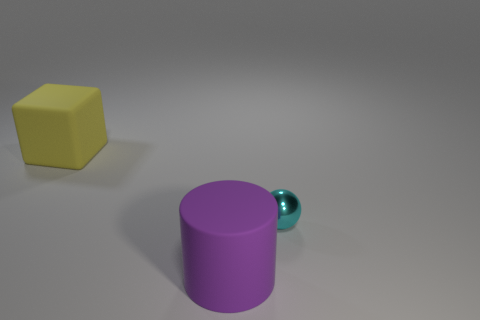Are there any other things that have the same material as the cyan thing?
Give a very brief answer. No. Do the big purple cylinder and the yellow object have the same material?
Make the answer very short. Yes. There is a large rubber thing in front of the big object that is left of the big thing in front of the metal thing; what color is it?
Provide a short and direct response. Purple. The tiny metallic object is what shape?
Offer a terse response. Sphere. Do the tiny object and the large matte thing to the left of the big purple rubber cylinder have the same color?
Give a very brief answer. No. Are there an equal number of purple cylinders that are in front of the purple rubber object and big brown metallic things?
Give a very brief answer. Yes. What number of cyan spheres are the same size as the purple rubber cylinder?
Your response must be concise. 0. Are any tiny metal things visible?
Offer a terse response. Yes. Is the shape of the matte thing on the right side of the rubber block the same as the matte object that is behind the matte cylinder?
Offer a very short reply. No. What number of small objects are yellow matte cubes or gray cylinders?
Keep it short and to the point. 0. 